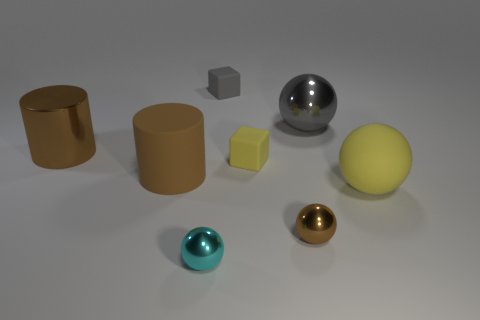There is a small metallic sphere that is in front of the brown sphere; is it the same color as the tiny sphere that is behind the small cyan shiny ball?
Ensure brevity in your answer.  No. Are there any brown metal things of the same shape as the brown rubber thing?
Your answer should be compact. Yes. The yellow rubber object that is the same size as the gray metallic ball is what shape?
Keep it short and to the point. Sphere. What number of small spheres have the same color as the shiny cylinder?
Offer a terse response. 1. How big is the rubber thing on the right side of the gray shiny thing?
Your answer should be compact. Large. How many green matte objects are the same size as the cyan metallic sphere?
Make the answer very short. 0. What color is the small object that is made of the same material as the gray block?
Provide a short and direct response. Yellow. Are there fewer cylinders in front of the big yellow rubber ball than blue balls?
Ensure brevity in your answer.  No. What shape is the large gray thing that is made of the same material as the tiny brown ball?
Provide a succinct answer. Sphere. What number of shiny things are either brown objects or big purple balls?
Give a very brief answer. 2. 